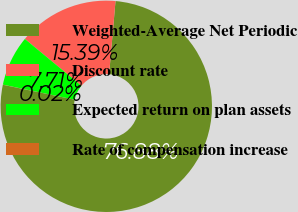Convert chart. <chart><loc_0><loc_0><loc_500><loc_500><pie_chart><fcel>Weighted-Average Net Periodic<fcel>Discount rate<fcel>Expected return on plan assets<fcel>Rate of compensation increase<nl><fcel>76.88%<fcel>15.39%<fcel>7.71%<fcel>0.02%<nl></chart> 